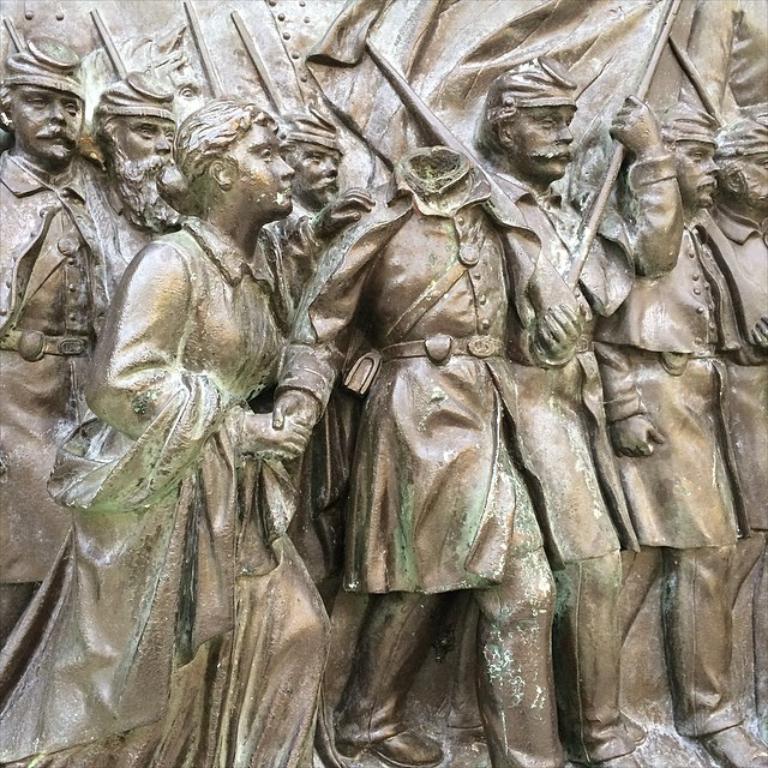Can you describe this image briefly? In this image I can see the statues of some people. 